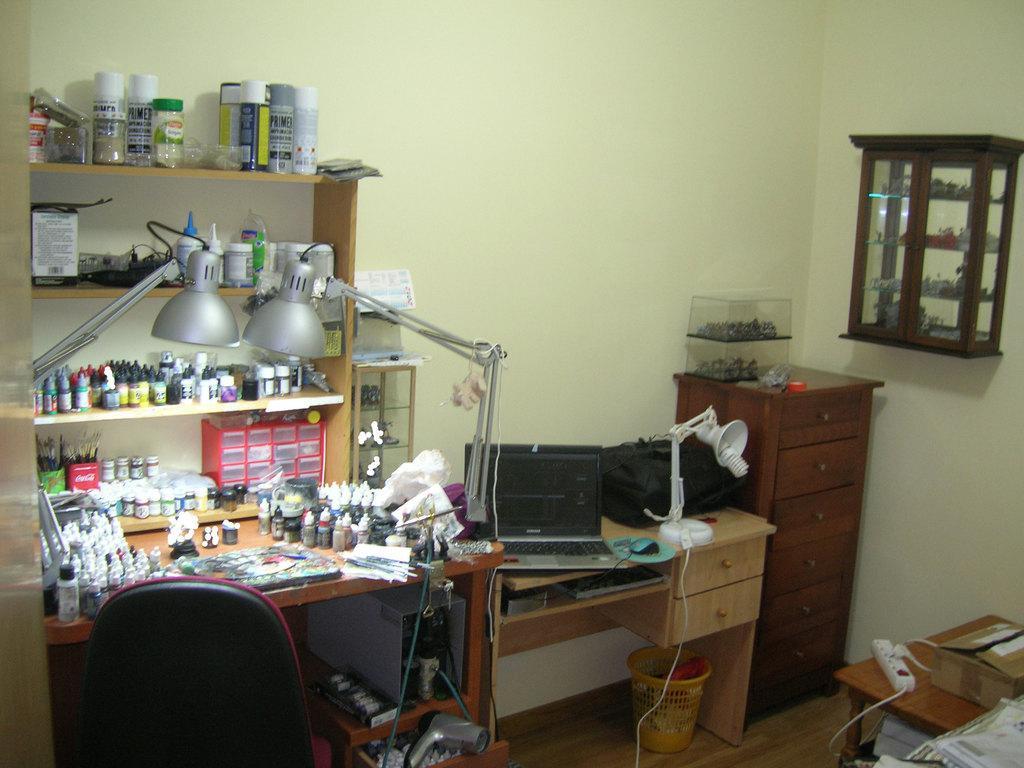Could you give a brief overview of what you see in this image? In this picture we can see on the floor there is a desk, tables, chair, drawers and a dustbin. On the desk there is a laptop, mouse, bag and some objects. On the tables there is a extension box, cardboard box, lights and some objects. In and on the shelves there are bottles and some objects. Behind the shelves there is a wall and on the wall there is a box. 